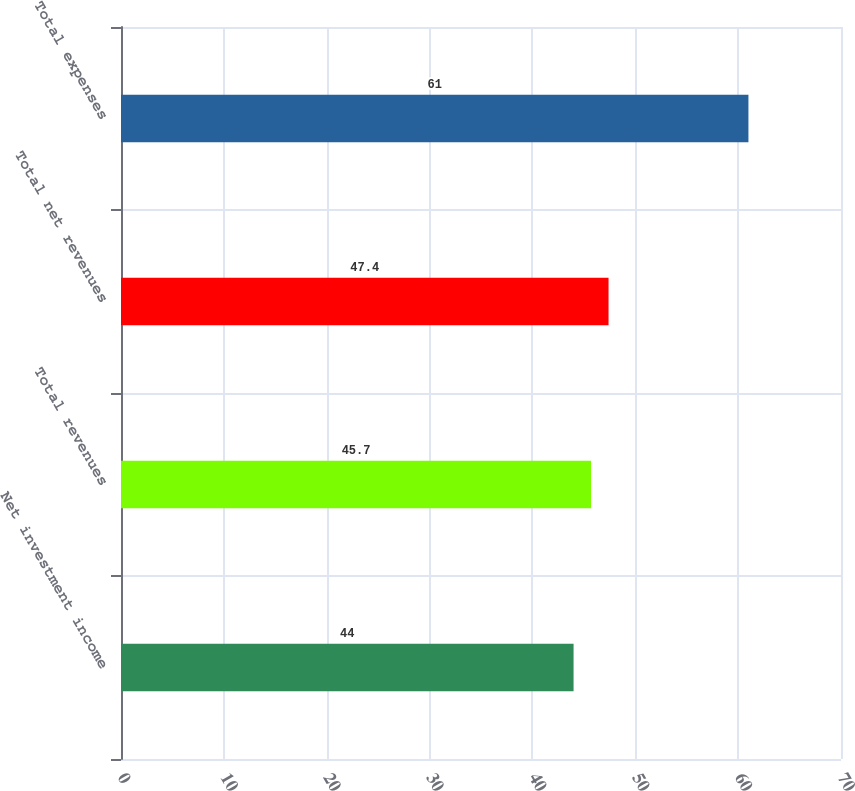Convert chart. <chart><loc_0><loc_0><loc_500><loc_500><bar_chart><fcel>Net investment income<fcel>Total revenues<fcel>Total net revenues<fcel>Total expenses<nl><fcel>44<fcel>45.7<fcel>47.4<fcel>61<nl></chart> 